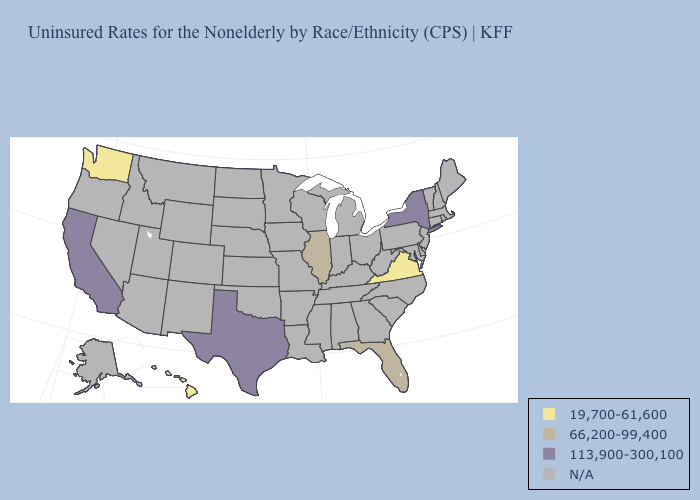What is the value of California?
Short answer required. 113,900-300,100. Name the states that have a value in the range 19,700-61,600?
Be succinct. Hawaii, Virginia, Washington. Does the first symbol in the legend represent the smallest category?
Quick response, please. Yes. Name the states that have a value in the range 66,200-99,400?
Answer briefly. Florida, Illinois. Which states have the lowest value in the USA?
Short answer required. Hawaii, Virginia, Washington. What is the highest value in states that border West Virginia?
Answer briefly. 19,700-61,600. Among the states that border Kentucky , which have the lowest value?
Concise answer only. Virginia. Among the states that border Arizona , which have the lowest value?
Short answer required. California. Name the states that have a value in the range 113,900-300,100?
Keep it brief. California, New York, Texas. What is the value of North Dakota?
Write a very short answer. N/A. 